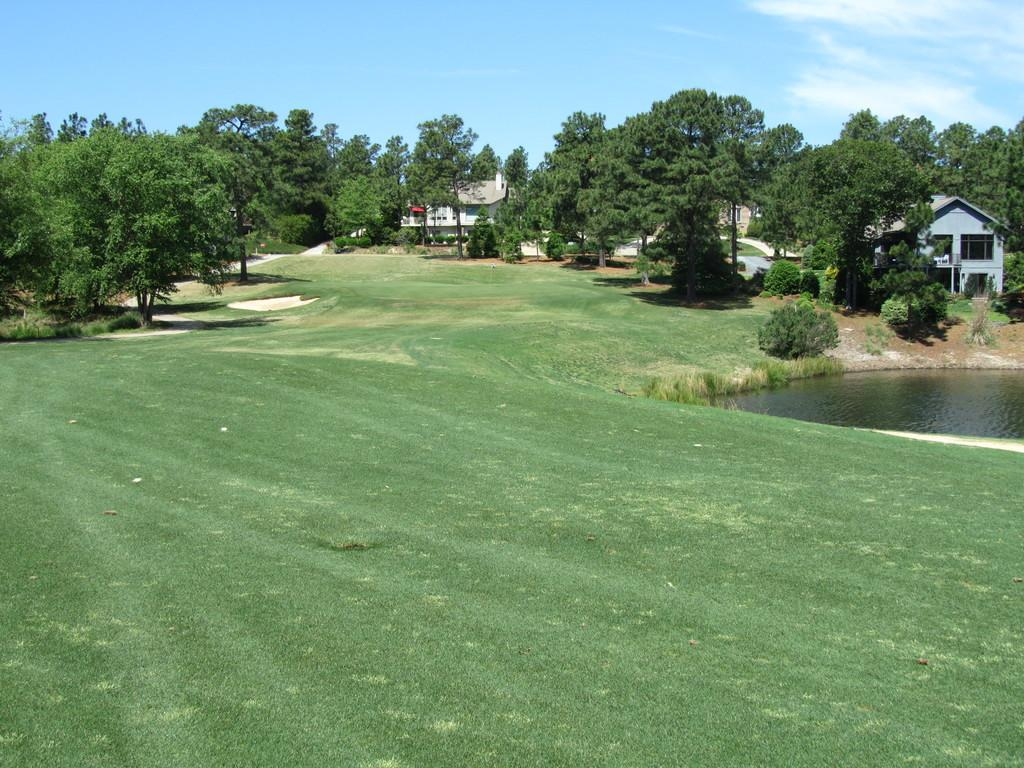What type of location is depicted in the image? The image appears to depict a garden. What can be seen on the right side of the image? There is a pond on the right side of the image. Can you identify any structures in the image? Yes, there is a house in the image. What type of vegetation is in the middle of the image? Trees are present in the middle of the image. What is visible at the top of the image? The sky is visible at the top of the image. What type of copper jewelry is the beggar wearing in the image? There is no beggar or copper jewelry present in the image. What does the mom say to the child in the image? There is no mom or child present in the image. 